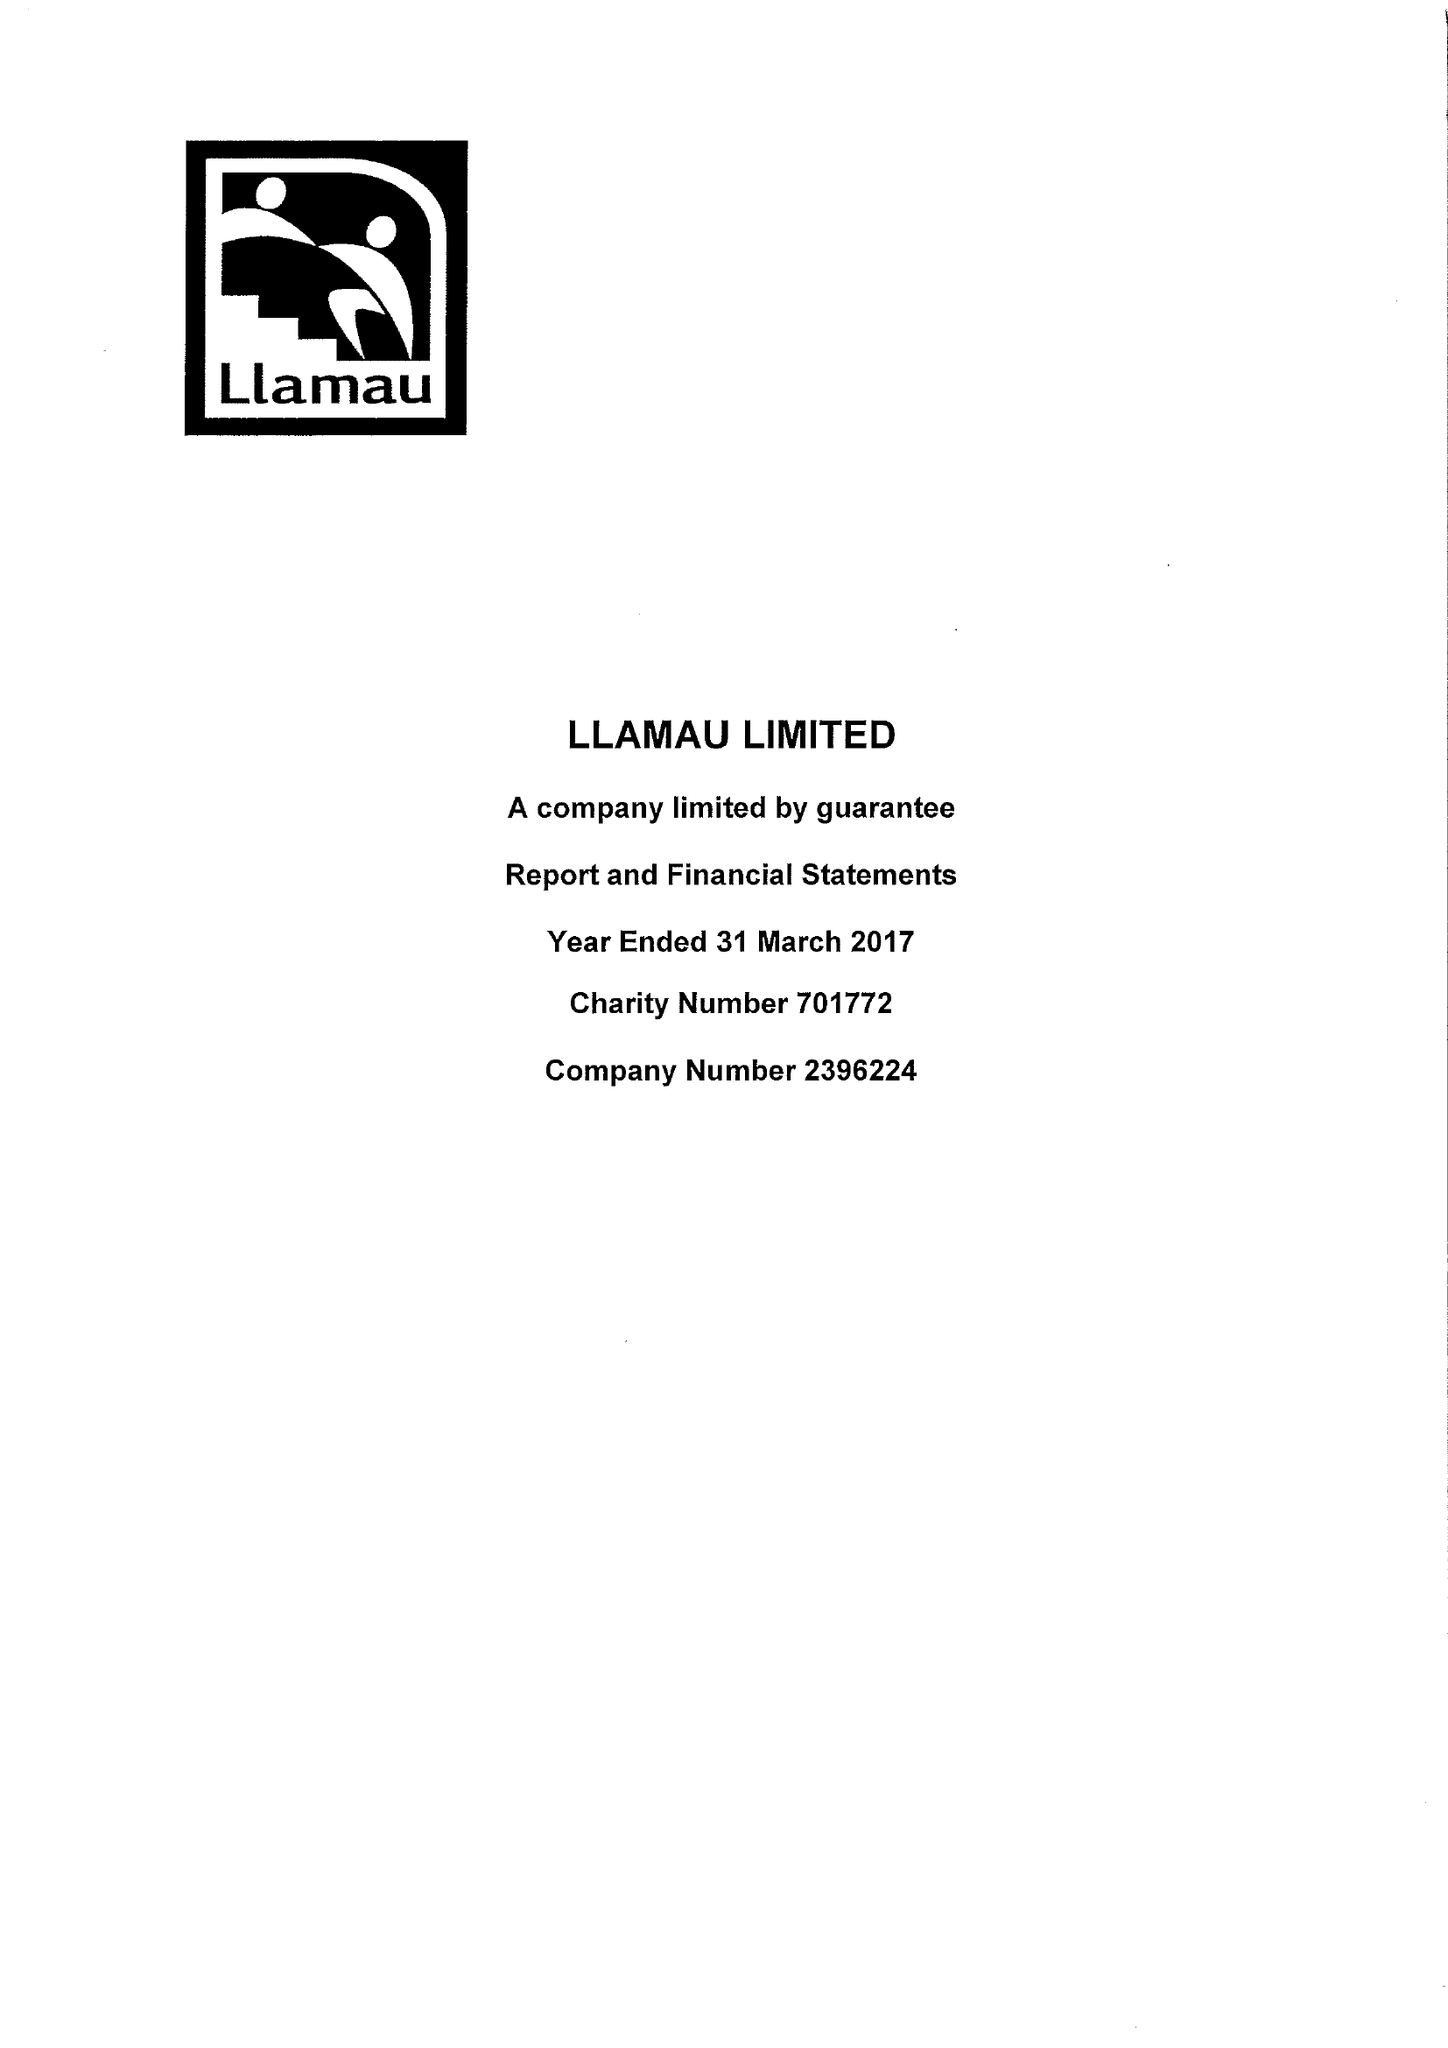What is the value for the spending_annually_in_british_pounds?
Answer the question using a single word or phrase. 10239538.00 